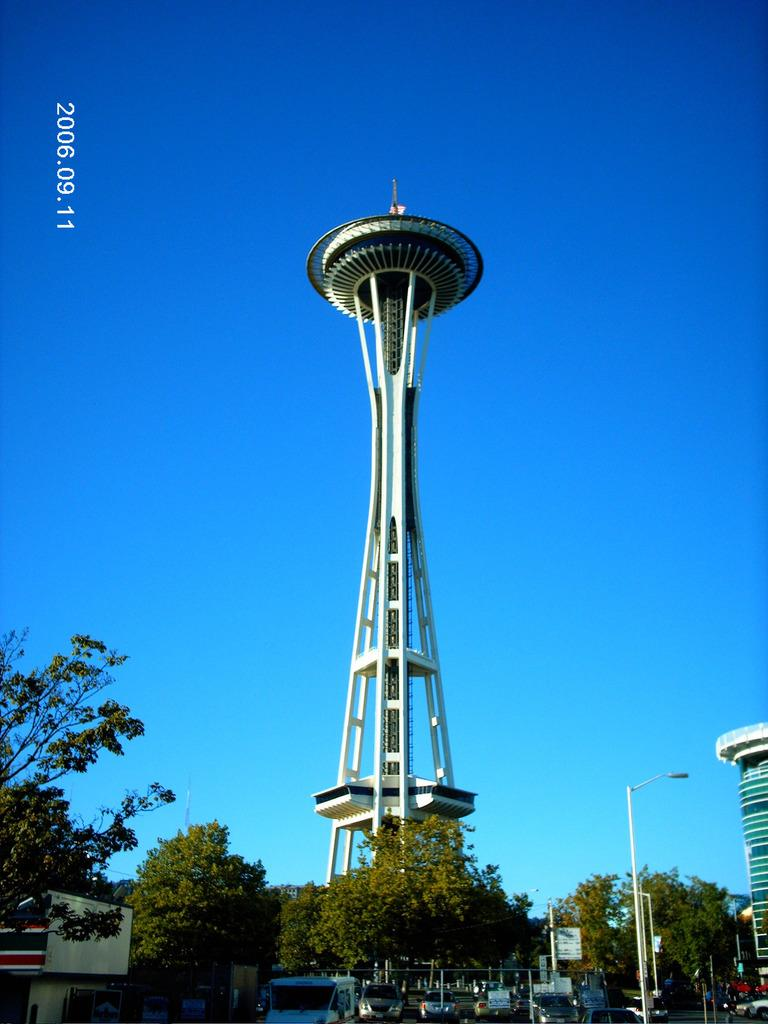What type of vegetation can be seen on the down side of the image? There are green color trees on the down side of the image. What is the main structure in the middle of the image? There is a big tower in the middle of the image. What color is the sky in the image? The sky is blue in the image. Where can the toothpaste be found in the image? There is no toothpaste present in the image. How many trucks are visible in the image? There are no trucks visible in the image. 